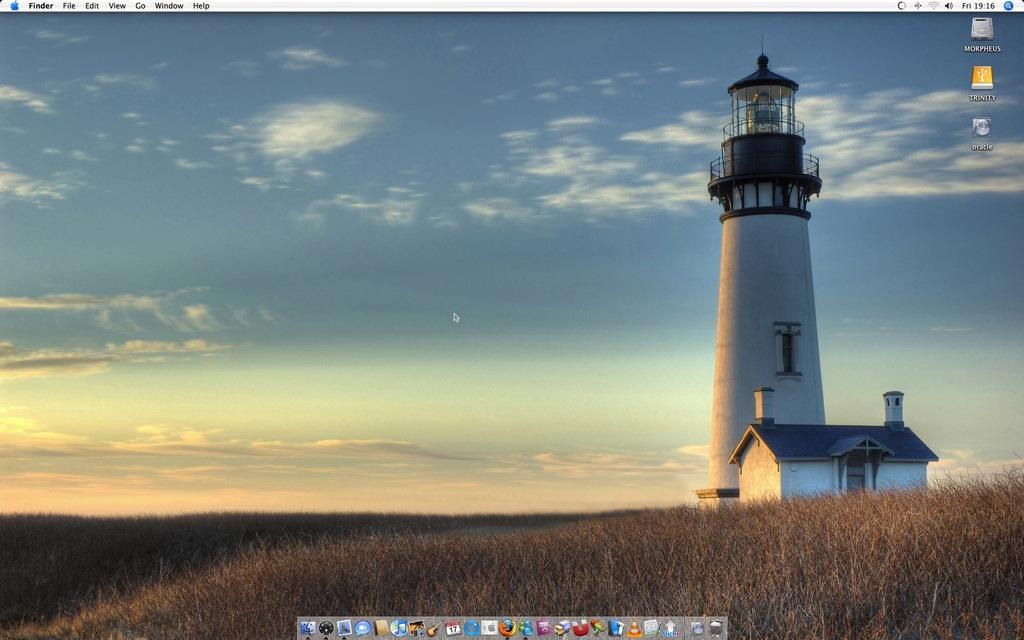What type of structure is in the image? There is a tower in the image. What other type of structure is in the image? There is a house in the image. What is at the bottom of the image? There is grass at the bottom of the image. What is visible at the top of the image? The sky is visible at the top of the image. What can be seen in the sky? Clouds are present in the sky. What type of payment is being made by the monkey in the image? There is no monkey present in the image, so no payment can be observed. 